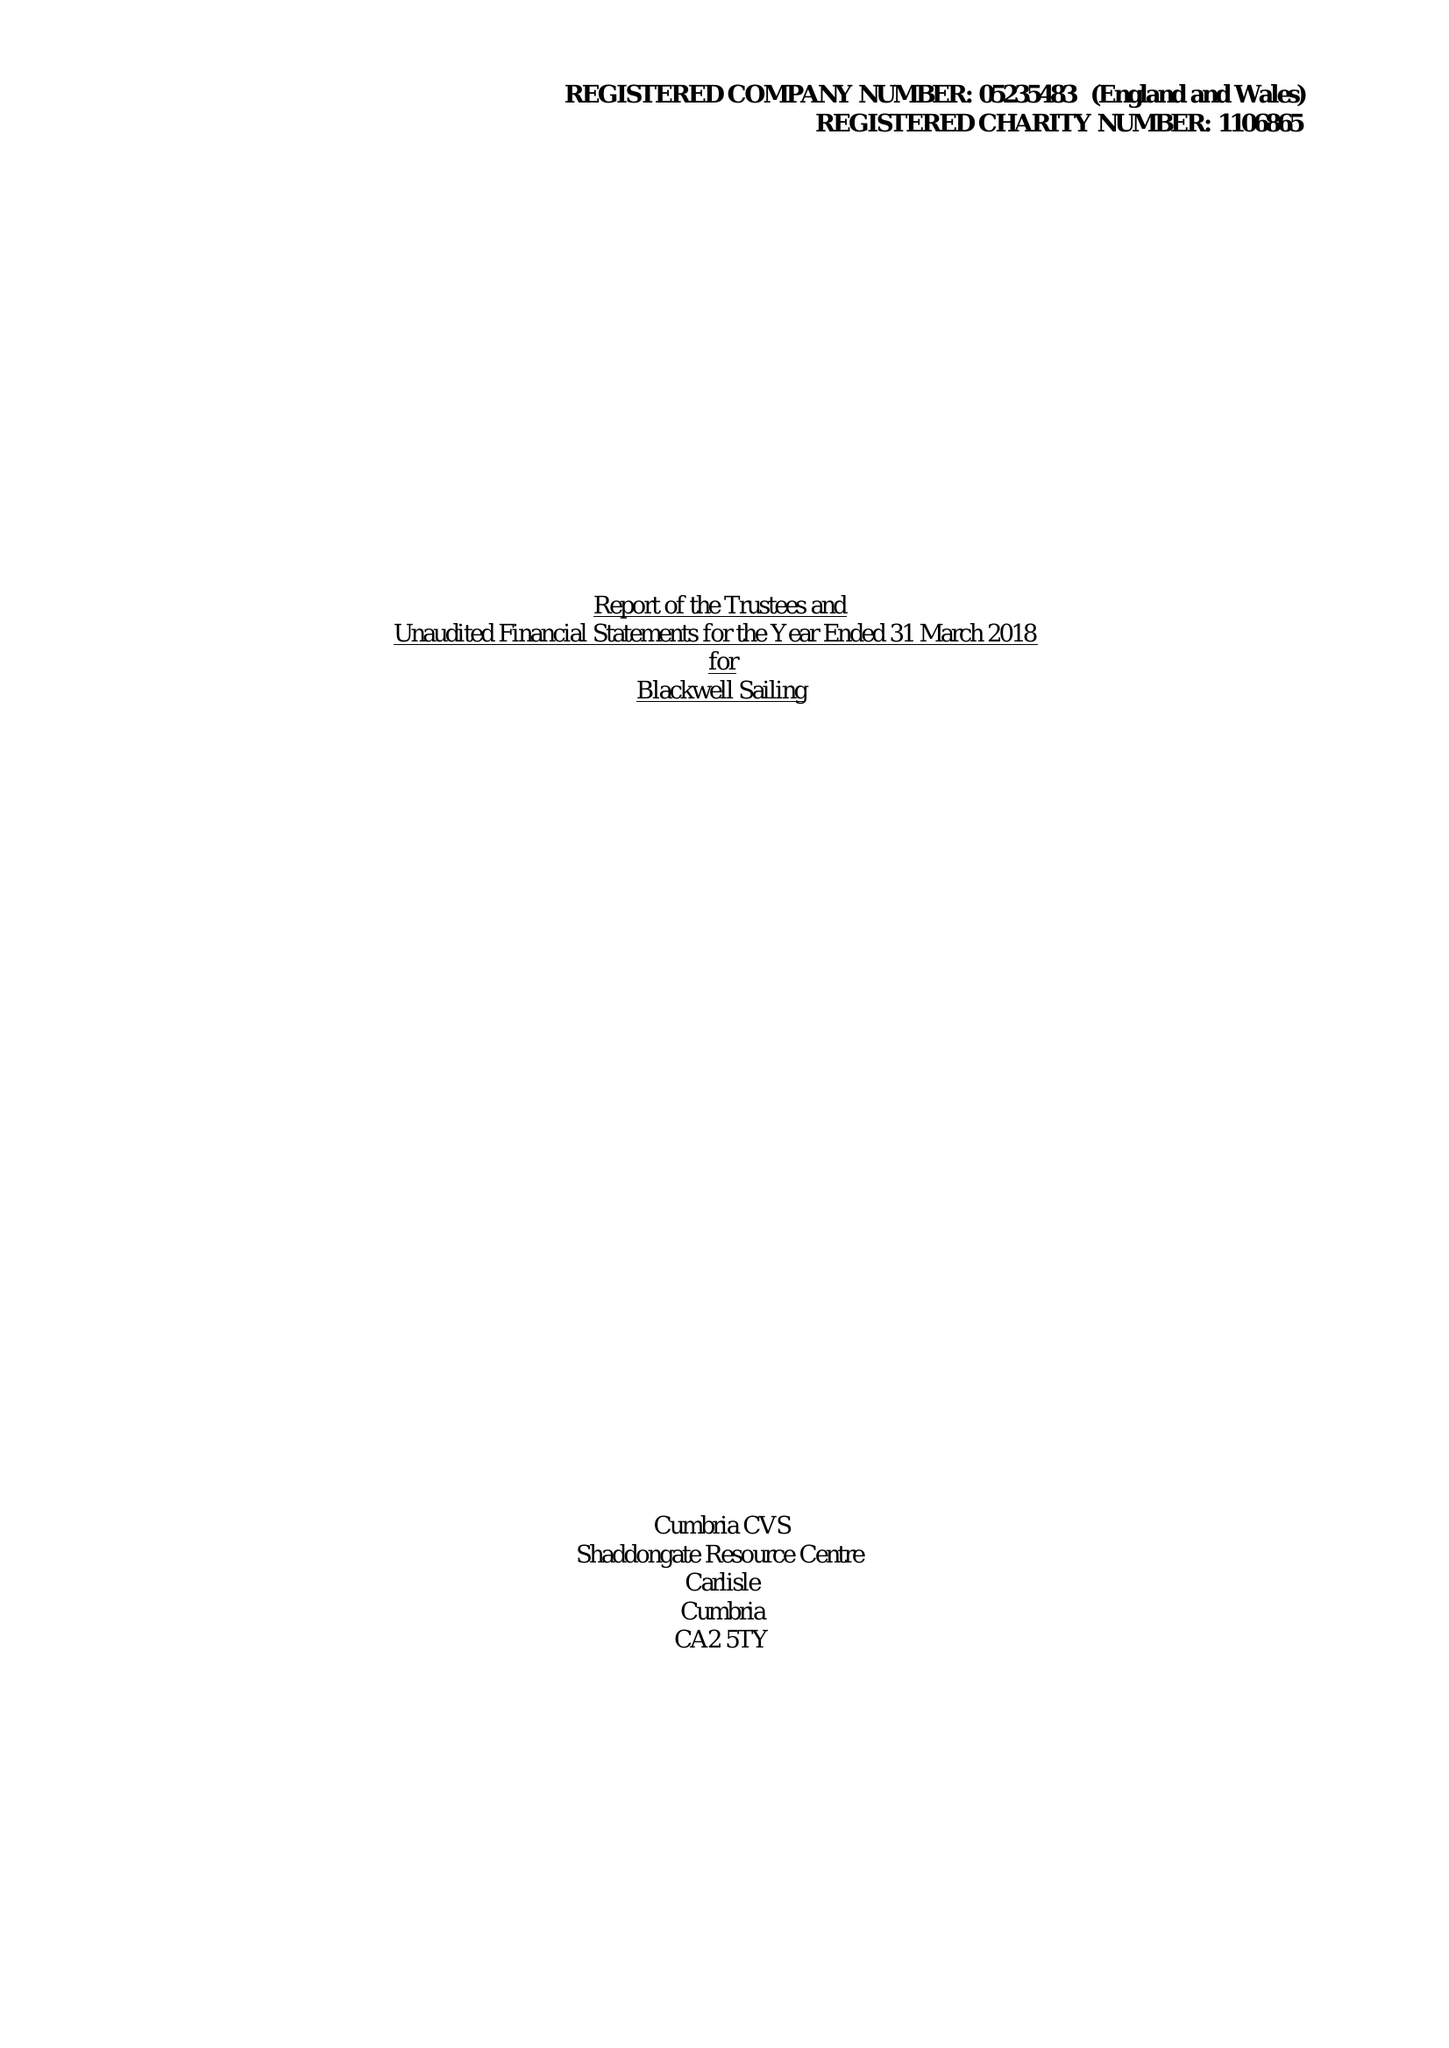What is the value for the address__postcode?
Answer the question using a single word or phrase. LA23 3HE 